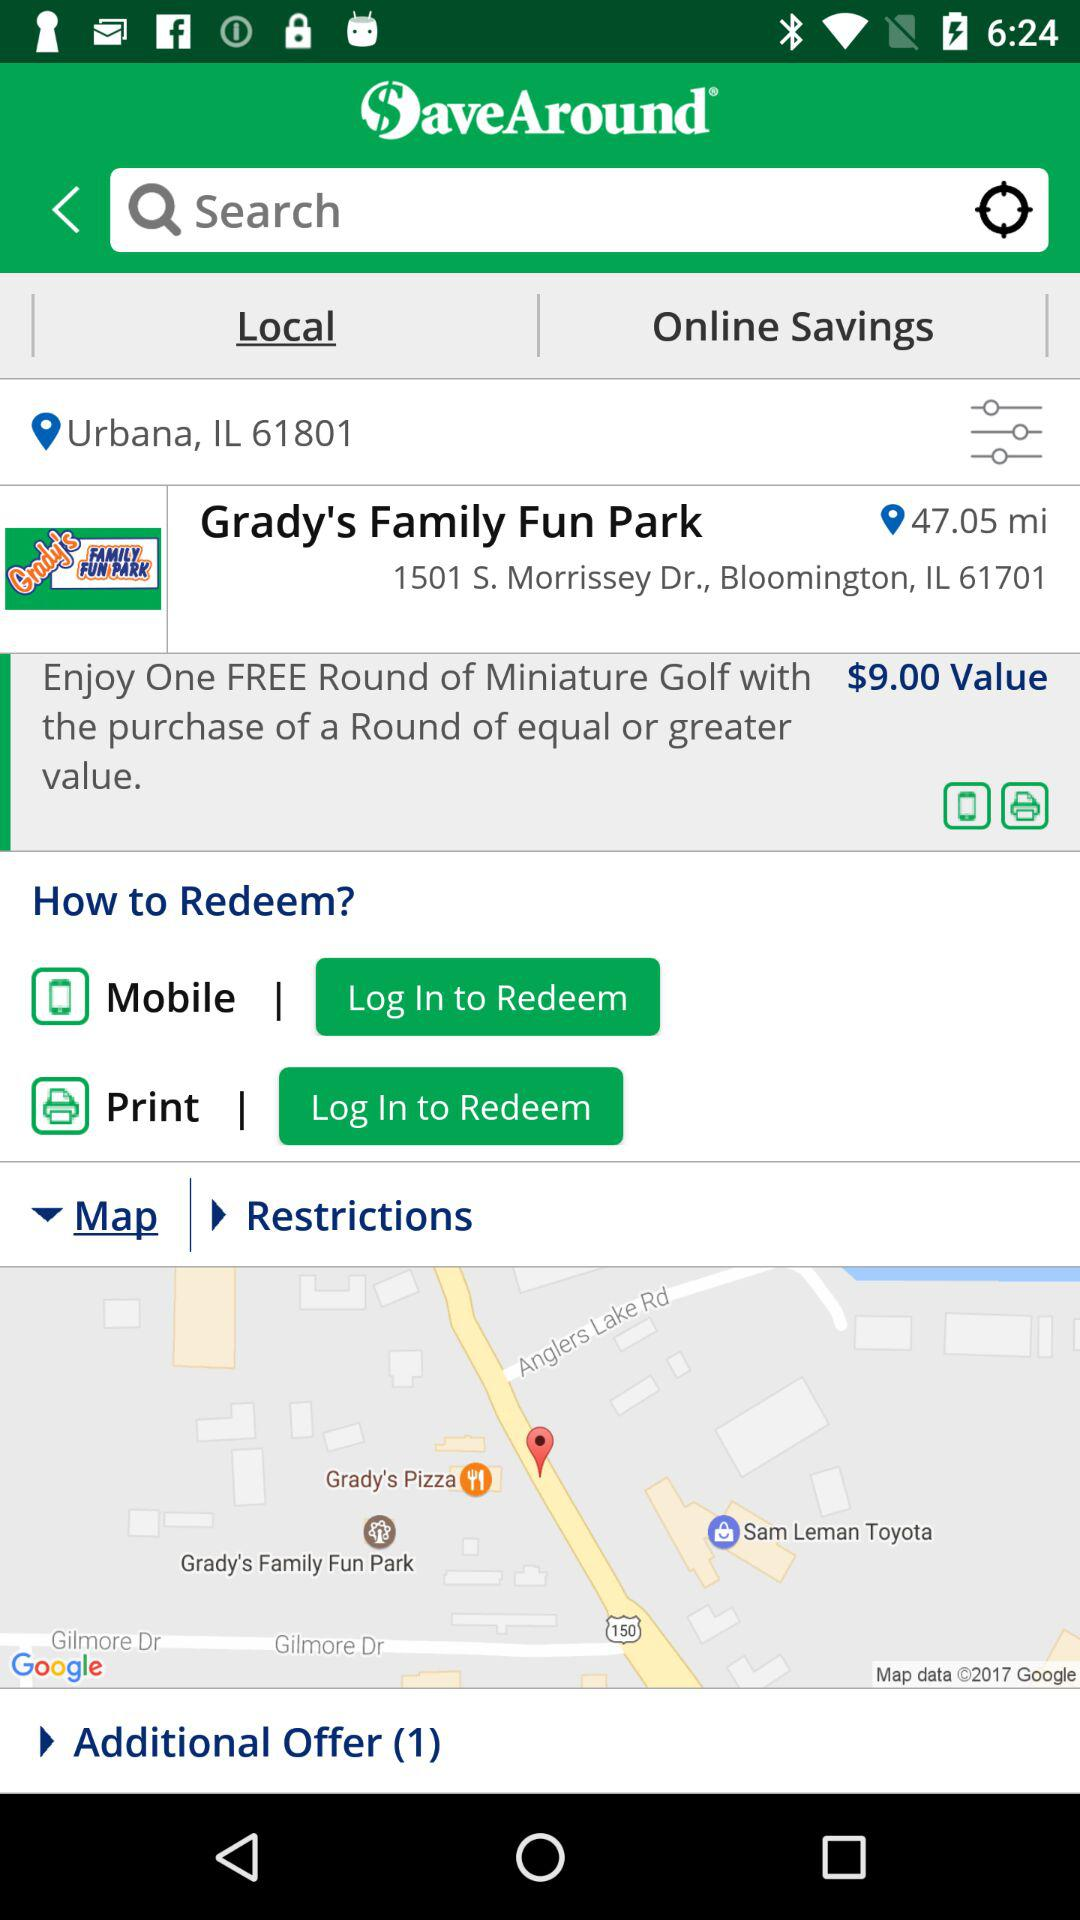What is the name of the park? The name is Grady's Family Fun Park. 